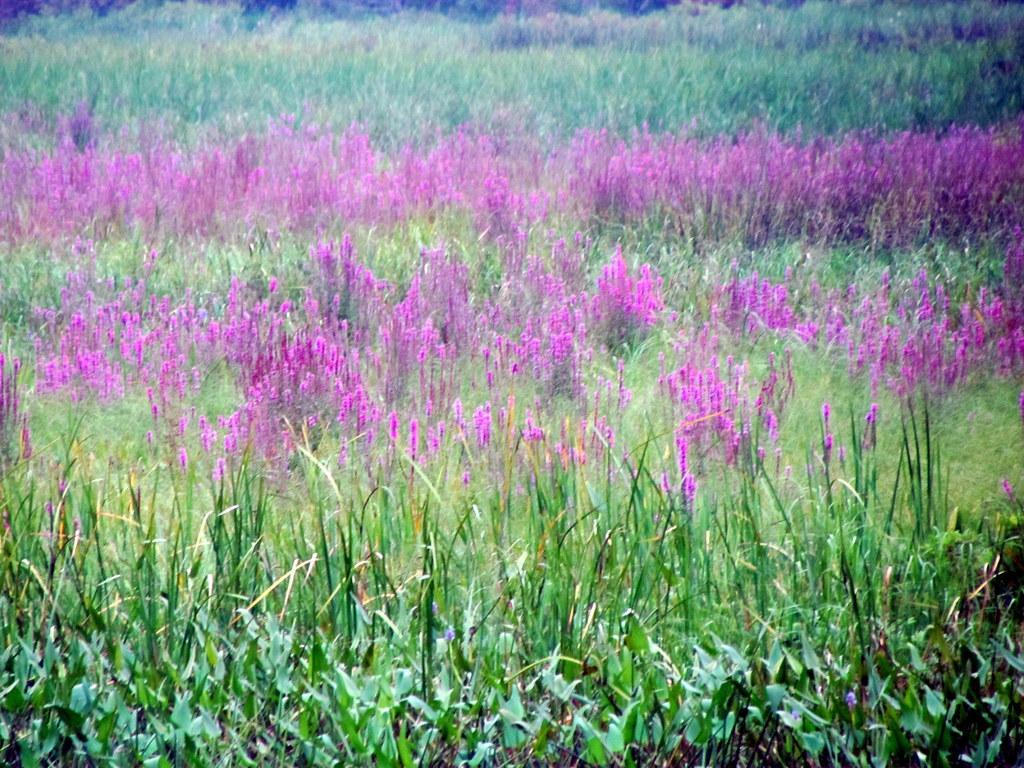How would you summarize this image in a sentence or two? This image consists of plants. In the middle, we can see the plants in pink color. At the bottom, there are green leaves. 